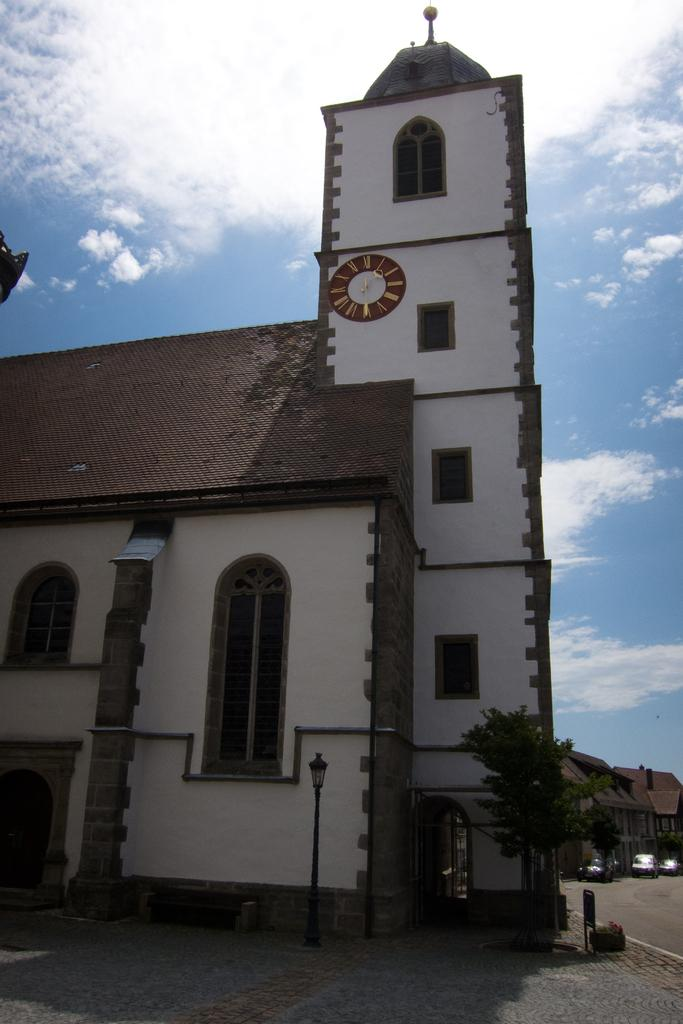What type of structure is present in the image? There is a building in the image. What colors are used on the building? The building has a cream and brown color. color. What type of vegetation is visible in the image? There are trees in the image. What color are the trees? The trees have a green color. What part of the natural environment is visible in the image? The sky is visible in the image. What colors are present in the sky? The sky has a blue and white color. Is there a library located in the back of the building in the image? There is no information about a library or any specific rooms within the building in the image. 